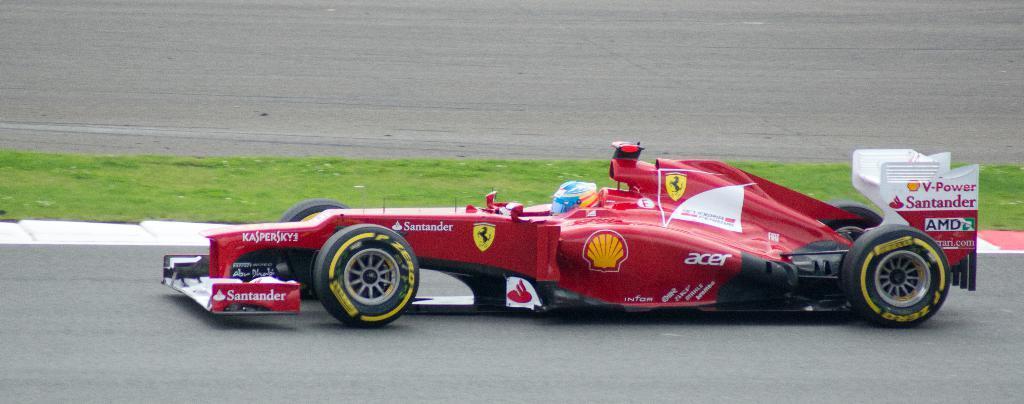Please provide a concise description of this image. In this image a person is driving a car. There is a grassy land at the center of the image. 